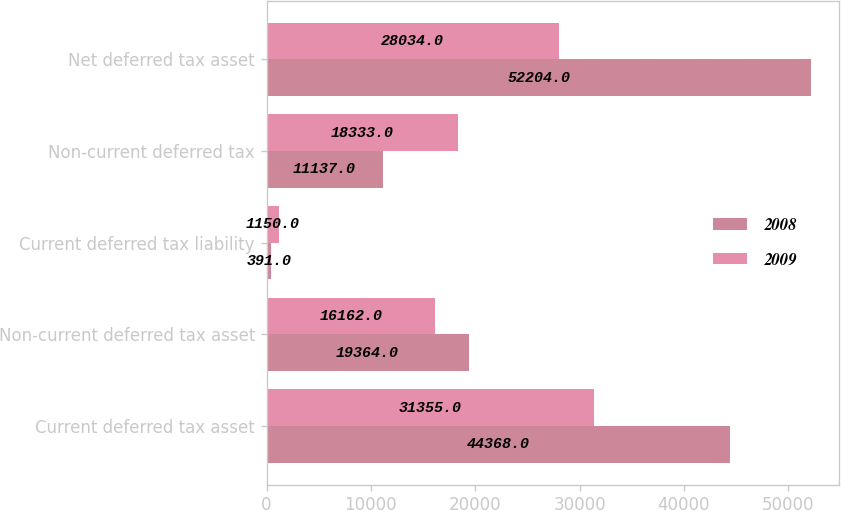Convert chart to OTSL. <chart><loc_0><loc_0><loc_500><loc_500><stacked_bar_chart><ecel><fcel>Current deferred tax asset<fcel>Non-current deferred tax asset<fcel>Current deferred tax liability<fcel>Non-current deferred tax<fcel>Net deferred tax asset<nl><fcel>2008<fcel>44368<fcel>19364<fcel>391<fcel>11137<fcel>52204<nl><fcel>2009<fcel>31355<fcel>16162<fcel>1150<fcel>18333<fcel>28034<nl></chart> 